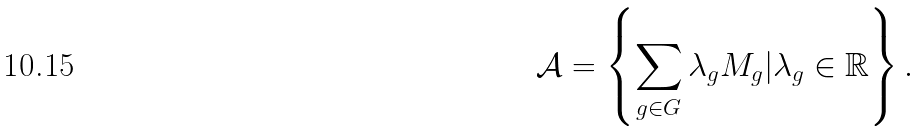Convert formula to latex. <formula><loc_0><loc_0><loc_500><loc_500>\mathcal { A } = \left \{ \sum _ { g \in G } \lambda _ { g } M _ { g } | \lambda _ { g } \in \mathbb { R } \right \} .</formula> 